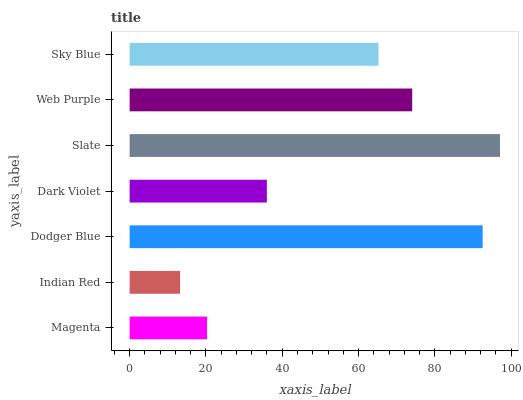Is Indian Red the minimum?
Answer yes or no. Yes. Is Slate the maximum?
Answer yes or no. Yes. Is Dodger Blue the minimum?
Answer yes or no. No. Is Dodger Blue the maximum?
Answer yes or no. No. Is Dodger Blue greater than Indian Red?
Answer yes or no. Yes. Is Indian Red less than Dodger Blue?
Answer yes or no. Yes. Is Indian Red greater than Dodger Blue?
Answer yes or no. No. Is Dodger Blue less than Indian Red?
Answer yes or no. No. Is Sky Blue the high median?
Answer yes or no. Yes. Is Sky Blue the low median?
Answer yes or no. Yes. Is Dark Violet the high median?
Answer yes or no. No. Is Slate the low median?
Answer yes or no. No. 